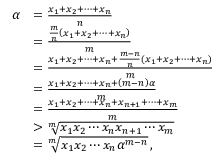Convert formula to latex. <formula><loc_0><loc_0><loc_500><loc_500>\begin{array} { r l } { \alpha } & { = { \frac { x _ { 1 } + x _ { 2 } + \cdots + x _ { n } } { n } } } \\ & { = { \frac { { \frac { m } { n } } \left ( x _ { 1 } + x _ { 2 } + \cdots + x _ { n } \right ) } { m } } } \\ & { = { \frac { x _ { 1 } + x _ { 2 } + \cdots + x _ { n } + { \frac { m - n } { n } } \left ( x _ { 1 } + x _ { 2 } + \cdots + x _ { n } \right ) } { m } } } \\ & { = { \frac { x _ { 1 } + x _ { 2 } + \cdots + x _ { n } + \left ( m - n \right ) \alpha } { m } } } \\ & { = { \frac { x _ { 1 } + x _ { 2 } + \cdots + x _ { n } + x _ { n + 1 } + \cdots + x _ { m } } { m } } } \\ & { > { \sqrt { [ } { m } ] { x _ { 1 } x _ { 2 } \cdots x _ { n } x _ { n + 1 } \cdots x _ { m } } } } \\ & { = { \sqrt { [ } { m } ] { x _ { 1 } x _ { 2 } \cdots x _ { n } \alpha ^ { m - n } } } \, , } \end{array}</formula> 